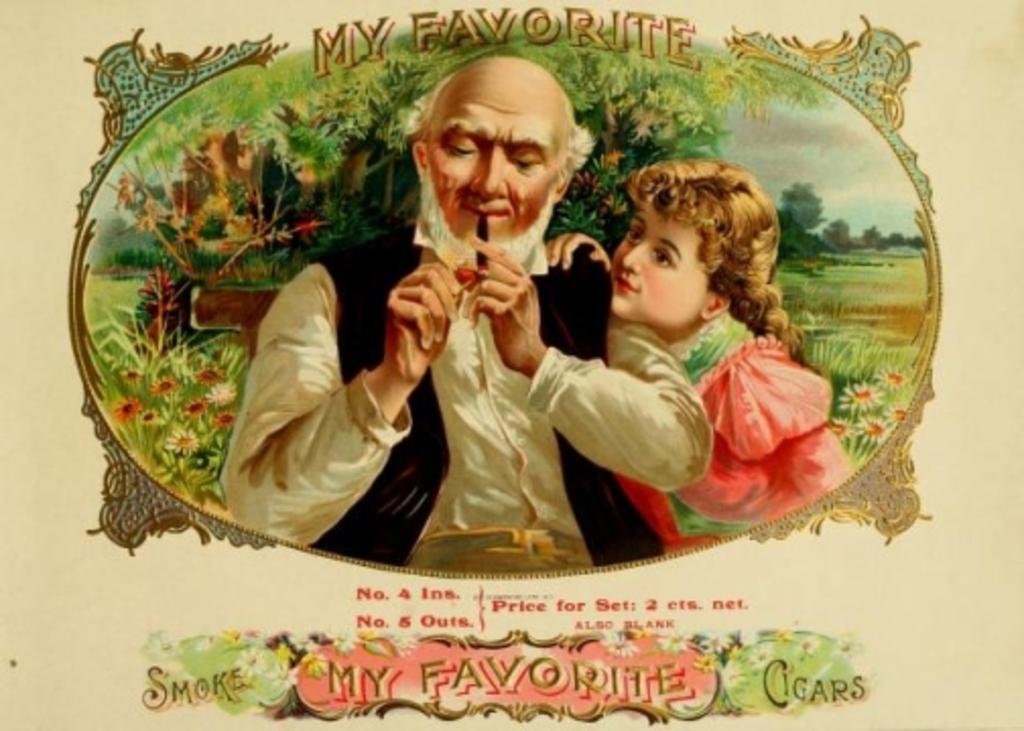What type of tobacco product is advertised?
Provide a short and direct response. Cigars. What is the number of ins and outs?
Your answer should be very brief. 4, 5. 